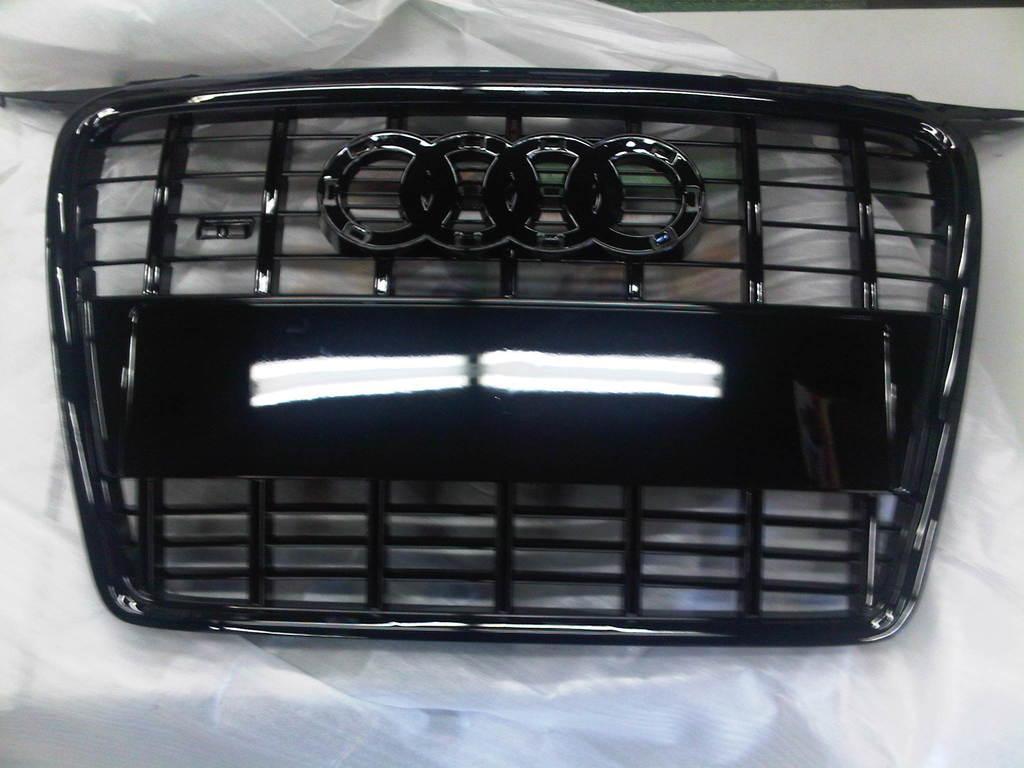In one or two sentences, can you explain what this image depicts? This is a zoomed in picture. In the center we can see the black color metal rods and a logo and we can see the reflection of lights on the surface of a black color object. In the background we can see a white color cloth and some white color object. 